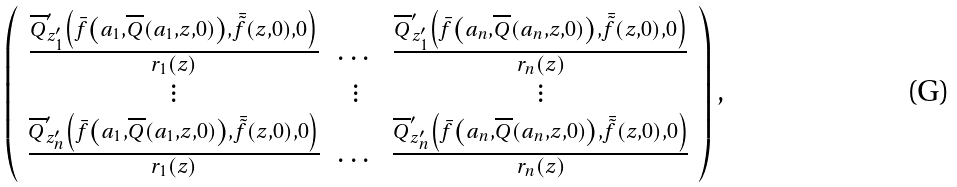Convert formula to latex. <formula><loc_0><loc_0><loc_500><loc_500>\left ( \begin{array} { c c c } \frac { \overline { Q } ^ { \prime } _ { z ^ { \prime } _ { 1 } } \left ( \bar { f } \left ( a _ { 1 } , \overline { Q } ( a _ { 1 } , z , 0 ) \right ) , \bar { \tilde { f } } ( z , 0 ) , 0 \right ) } { r _ { 1 } ( z ) } & \dots & \frac { \overline { Q } ^ { \prime } _ { z ^ { \prime } _ { 1 } } \left ( \bar { f } \left ( a _ { n } , \overline { Q } ( a _ { n } , z , 0 ) \right ) , \bar { \tilde { f } } ( z , 0 ) , 0 \right ) } { r _ { n } ( z ) } \\ \vdots & \vdots & \vdots \\ \frac { \overline { Q } ^ { \prime } _ { z ^ { \prime } _ { n } } \left ( \bar { f } \left ( a _ { 1 } , \overline { Q } ( a _ { 1 } , z , 0 ) \right ) , \bar { \tilde { f } } ( z , 0 ) , 0 \right ) } { r _ { 1 } ( z ) } & \dots & \frac { \overline { Q } ^ { \prime } _ { z ^ { \prime } _ { n } } \left ( \bar { f } \left ( a _ { n } , \overline { Q } ( a _ { n } , z , 0 ) \right ) , \bar { \tilde { f } } ( z , 0 ) , 0 \right ) } { r _ { n } ( z ) } \end{array} \right ) ,</formula> 